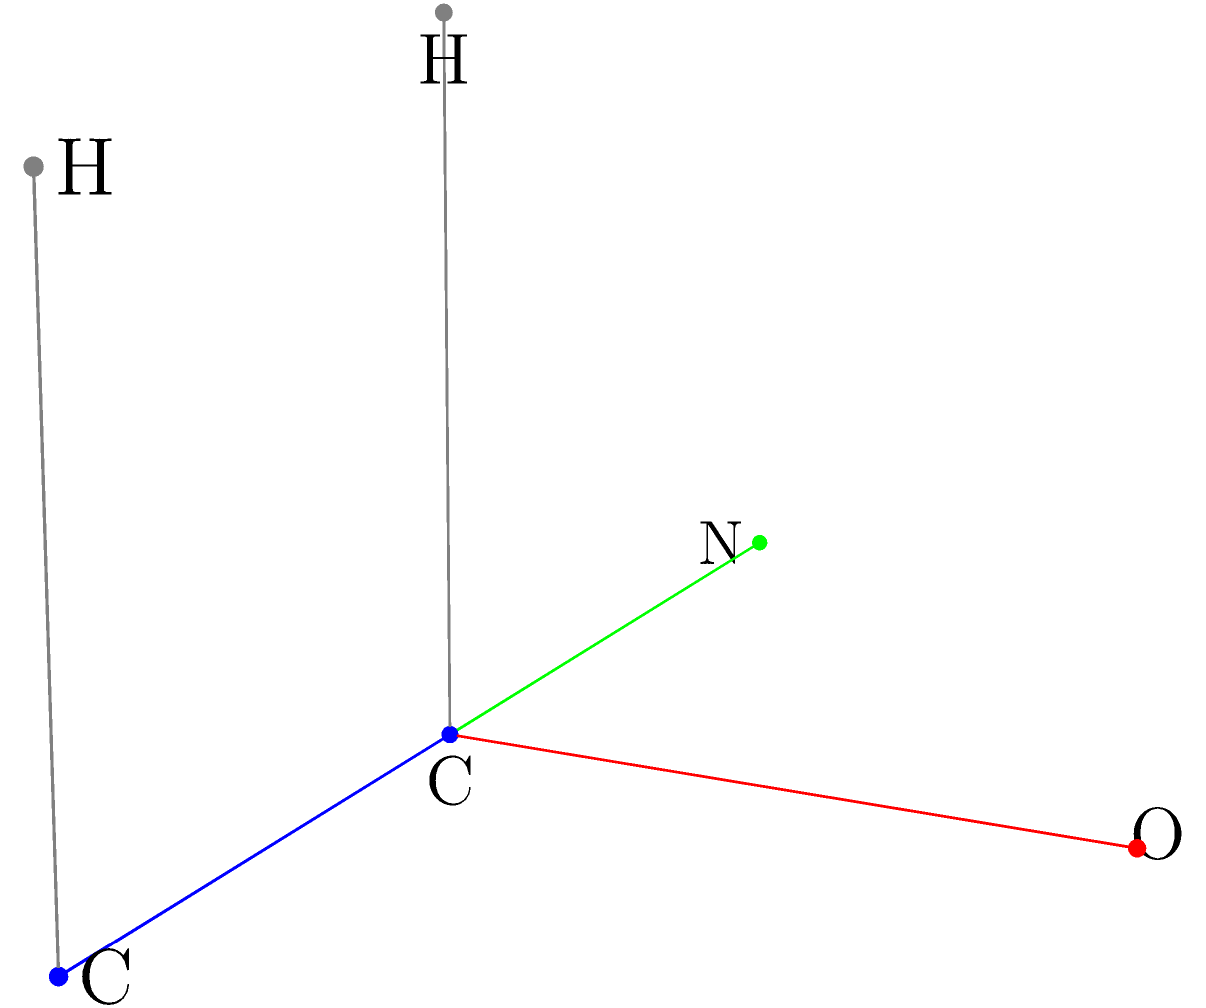Identify the point group of the molecule shown in the 3D model above, which represents a common functional group found in many pharmaceutical compounds. How would this point group classification influence the molecule's spectroscopic properties? To identify the point group of this molecule, we need to analyze its symmetry elements:

1. The molecule has a plane of symmetry that bisects the O-C-N angle.
2. There is no center of inversion.
3. There is no proper rotation axis (C_n) with n > 1.
4. There is one C_1 axis, which is trivial for all molecules.
5. There is one mirror plane (σ) perpendicular to the C_1 axis.

Based on these observations, we can conclude that this molecule belongs to the C_s point group.

The C_s point group classification influences the molecule's spectroscopic properties in the following ways:

1. Infrared (IR) spectroscopy: All vibrational modes will be either symmetric (A') or antisymmetric (A") with respect to the mirror plane. This affects the selection rules for IR activity.

2. Raman spectroscopy: Similar to IR, all vibrational modes will be classified as A' or A", influencing the Raman activity of the modes.

3. Nuclear Magnetic Resonance (NMR): The symmetry plane can make certain nuclei equivalent, affecting the number of signals observed in the NMR spectrum.

4. Electronic spectroscopy: The symmetry affects the selection rules for electronic transitions, influencing the UV-Vis spectrum of the molecule.

Understanding the point group is crucial for predicting and interpreting spectroscopic data, which is essential in pharmaceutical research for structure elucidation and quality control of drug molecules.
Answer: C_s point group 